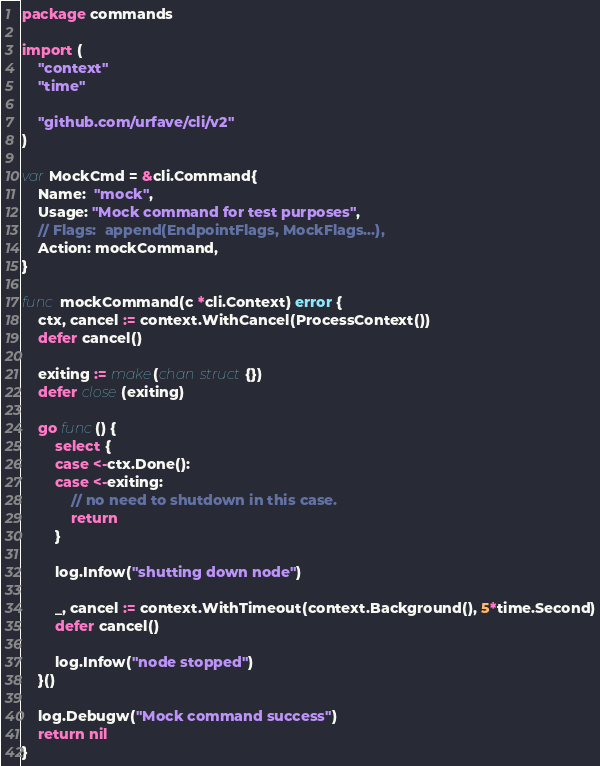Convert code to text. <code><loc_0><loc_0><loc_500><loc_500><_Go_>package commands

import (
	"context"
	"time"

	"github.com/urfave/cli/v2"
)

var MockCmd = &cli.Command{
	Name:  "mock",
	Usage: "Mock command for test purposes",
	// Flags:  append(EndpointFlags, MockFlags...),
	Action: mockCommand,
}

func mockCommand(c *cli.Context) error {
	ctx, cancel := context.WithCancel(ProcessContext())
	defer cancel()

	exiting := make(chan struct{})
	defer close(exiting)

	go func() {
		select {
		case <-ctx.Done():
		case <-exiting:
			// no need to shutdown in this case.
			return
		}

		log.Infow("shutting down node")

		_, cancel := context.WithTimeout(context.Background(), 5*time.Second)
		defer cancel()

		log.Infow("node stopped")
	}()

	log.Debugw("Mock command success")
	return nil
}
</code> 